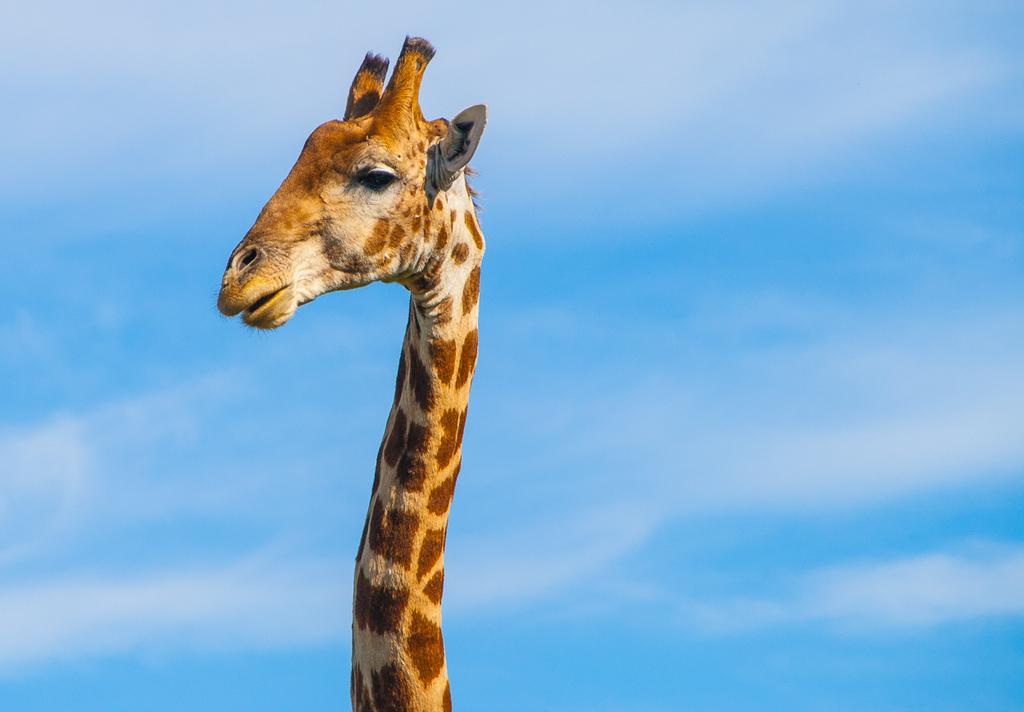Please provide a concise description of this image. In this image in the front there is a giraffe and the sky is cloudy. 